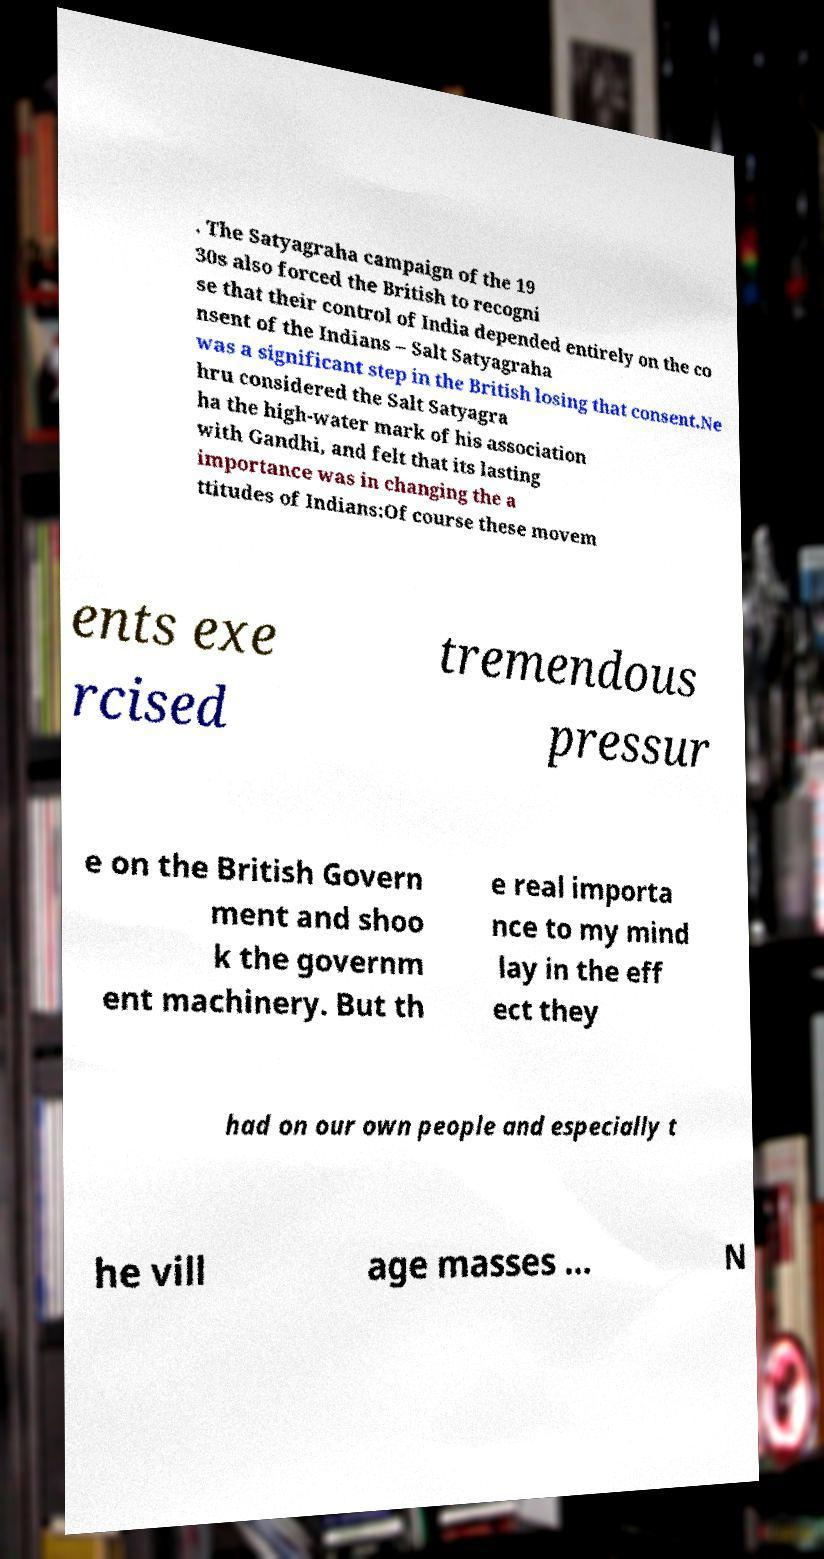There's text embedded in this image that I need extracted. Can you transcribe it verbatim? . The Satyagraha campaign of the 19 30s also forced the British to recogni se that their control of India depended entirely on the co nsent of the Indians – Salt Satyagraha was a significant step in the British losing that consent.Ne hru considered the Salt Satyagra ha the high-water mark of his association with Gandhi, and felt that its lasting importance was in changing the a ttitudes of Indians:Of course these movem ents exe rcised tremendous pressur e on the British Govern ment and shoo k the governm ent machinery. But th e real importa nce to my mind lay in the eff ect they had on our own people and especially t he vill age masses ... N 